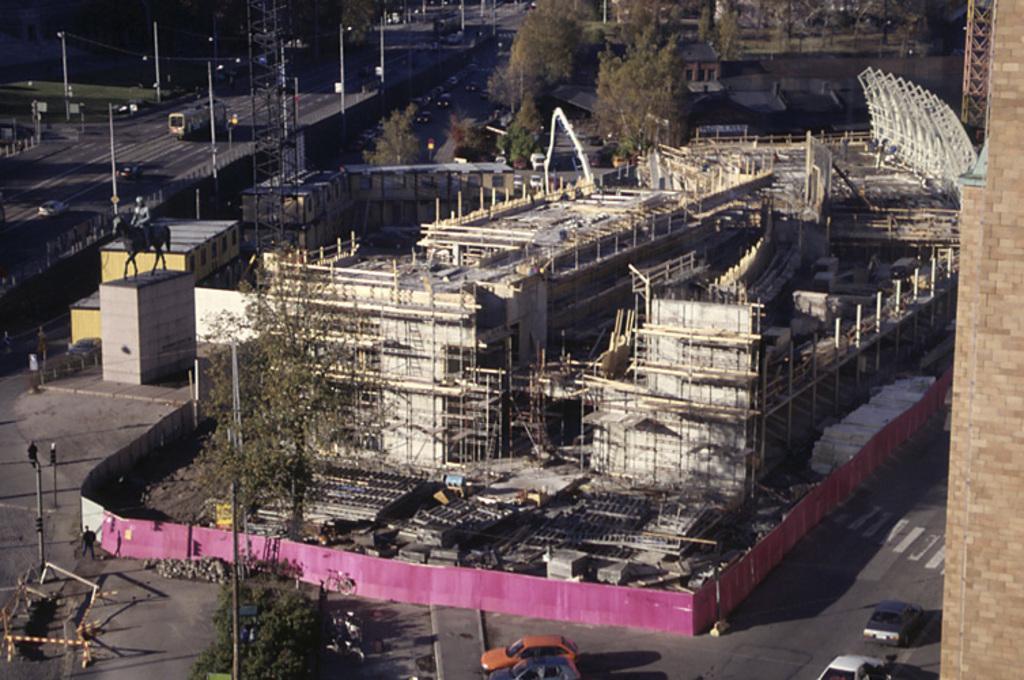How would you summarize this image in a sentence or two? This picture shows few under construction buildings and we see a statue of a man on the horse and we see trees and few buildings on the side and we see vehicles moving on the road and we see few poles and few cars parked. 